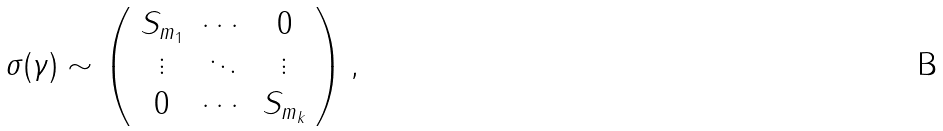Convert formula to latex. <formula><loc_0><loc_0><loc_500><loc_500>\sigma ( \gamma ) \sim \left ( \begin{array} { c c c } S _ { m _ { 1 } } & \cdots & 0 \\ \vdots & \ddots & \vdots \\ 0 & \cdots & S _ { m _ { k } } \end{array} \right ) ,</formula> 